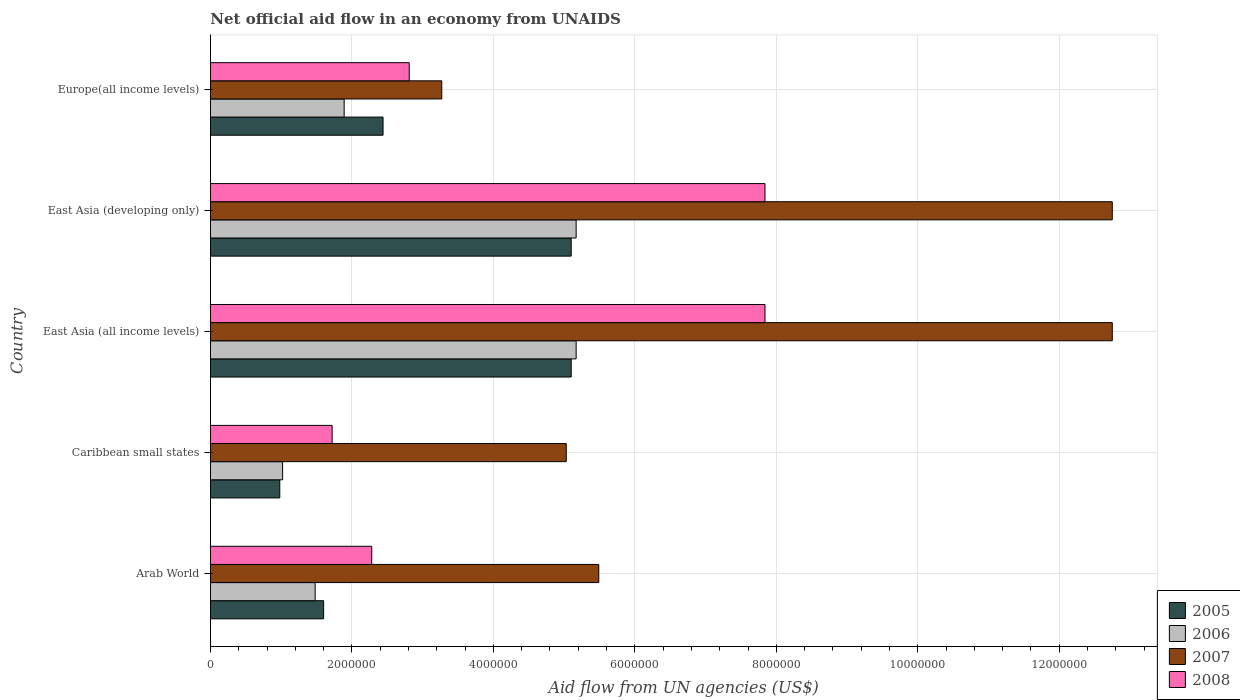How many different coloured bars are there?
Keep it short and to the point. 4. Are the number of bars on each tick of the Y-axis equal?
Offer a terse response. Yes. What is the label of the 4th group of bars from the top?
Give a very brief answer. Caribbean small states. In how many cases, is the number of bars for a given country not equal to the number of legend labels?
Provide a succinct answer. 0. What is the net official aid flow in 2008 in East Asia (developing only)?
Your answer should be compact. 7.84e+06. Across all countries, what is the maximum net official aid flow in 2008?
Provide a succinct answer. 7.84e+06. Across all countries, what is the minimum net official aid flow in 2007?
Give a very brief answer. 3.27e+06. In which country was the net official aid flow in 2005 maximum?
Offer a terse response. East Asia (all income levels). In which country was the net official aid flow in 2008 minimum?
Offer a very short reply. Caribbean small states. What is the total net official aid flow in 2006 in the graph?
Provide a short and direct response. 1.47e+07. What is the difference between the net official aid flow in 2007 in East Asia (developing only) and that in Europe(all income levels)?
Your answer should be compact. 9.48e+06. What is the difference between the net official aid flow in 2005 in Arab World and the net official aid flow in 2008 in Caribbean small states?
Your response must be concise. -1.20e+05. What is the average net official aid flow in 2006 per country?
Your answer should be compact. 2.95e+06. What is the difference between the net official aid flow in 2005 and net official aid flow in 2006 in East Asia (all income levels)?
Provide a succinct answer. -7.00e+04. In how many countries, is the net official aid flow in 2006 greater than 10000000 US$?
Ensure brevity in your answer.  0. What is the ratio of the net official aid flow in 2008 in Caribbean small states to that in East Asia (developing only)?
Your answer should be very brief. 0.22. Is the difference between the net official aid flow in 2005 in Arab World and East Asia (developing only) greater than the difference between the net official aid flow in 2006 in Arab World and East Asia (developing only)?
Offer a terse response. Yes. What is the difference between the highest and the second highest net official aid flow in 2008?
Provide a short and direct response. 0. What is the difference between the highest and the lowest net official aid flow in 2006?
Make the answer very short. 4.15e+06. In how many countries, is the net official aid flow in 2006 greater than the average net official aid flow in 2006 taken over all countries?
Your answer should be very brief. 2. What does the 2nd bar from the top in Caribbean small states represents?
Your answer should be very brief. 2007. Is it the case that in every country, the sum of the net official aid flow in 2005 and net official aid flow in 2007 is greater than the net official aid flow in 2008?
Provide a short and direct response. Yes. Does the graph contain grids?
Offer a terse response. Yes. Where does the legend appear in the graph?
Ensure brevity in your answer.  Bottom right. What is the title of the graph?
Your answer should be very brief. Net official aid flow in an economy from UNAIDS. What is the label or title of the X-axis?
Offer a very short reply. Aid flow from UN agencies (US$). What is the label or title of the Y-axis?
Your answer should be compact. Country. What is the Aid flow from UN agencies (US$) of 2005 in Arab World?
Make the answer very short. 1.60e+06. What is the Aid flow from UN agencies (US$) of 2006 in Arab World?
Provide a short and direct response. 1.48e+06. What is the Aid flow from UN agencies (US$) of 2007 in Arab World?
Your response must be concise. 5.49e+06. What is the Aid flow from UN agencies (US$) in 2008 in Arab World?
Ensure brevity in your answer.  2.28e+06. What is the Aid flow from UN agencies (US$) in 2005 in Caribbean small states?
Your answer should be compact. 9.80e+05. What is the Aid flow from UN agencies (US$) in 2006 in Caribbean small states?
Give a very brief answer. 1.02e+06. What is the Aid flow from UN agencies (US$) in 2007 in Caribbean small states?
Your answer should be compact. 5.03e+06. What is the Aid flow from UN agencies (US$) in 2008 in Caribbean small states?
Your response must be concise. 1.72e+06. What is the Aid flow from UN agencies (US$) of 2005 in East Asia (all income levels)?
Make the answer very short. 5.10e+06. What is the Aid flow from UN agencies (US$) of 2006 in East Asia (all income levels)?
Ensure brevity in your answer.  5.17e+06. What is the Aid flow from UN agencies (US$) of 2007 in East Asia (all income levels)?
Provide a short and direct response. 1.28e+07. What is the Aid flow from UN agencies (US$) of 2008 in East Asia (all income levels)?
Your response must be concise. 7.84e+06. What is the Aid flow from UN agencies (US$) of 2005 in East Asia (developing only)?
Offer a terse response. 5.10e+06. What is the Aid flow from UN agencies (US$) of 2006 in East Asia (developing only)?
Your answer should be very brief. 5.17e+06. What is the Aid flow from UN agencies (US$) of 2007 in East Asia (developing only)?
Give a very brief answer. 1.28e+07. What is the Aid flow from UN agencies (US$) in 2008 in East Asia (developing only)?
Give a very brief answer. 7.84e+06. What is the Aid flow from UN agencies (US$) in 2005 in Europe(all income levels)?
Offer a terse response. 2.44e+06. What is the Aid flow from UN agencies (US$) of 2006 in Europe(all income levels)?
Offer a very short reply. 1.89e+06. What is the Aid flow from UN agencies (US$) of 2007 in Europe(all income levels)?
Ensure brevity in your answer.  3.27e+06. What is the Aid flow from UN agencies (US$) of 2008 in Europe(all income levels)?
Offer a very short reply. 2.81e+06. Across all countries, what is the maximum Aid flow from UN agencies (US$) of 2005?
Offer a terse response. 5.10e+06. Across all countries, what is the maximum Aid flow from UN agencies (US$) of 2006?
Provide a short and direct response. 5.17e+06. Across all countries, what is the maximum Aid flow from UN agencies (US$) of 2007?
Provide a short and direct response. 1.28e+07. Across all countries, what is the maximum Aid flow from UN agencies (US$) in 2008?
Offer a very short reply. 7.84e+06. Across all countries, what is the minimum Aid flow from UN agencies (US$) of 2005?
Your answer should be very brief. 9.80e+05. Across all countries, what is the minimum Aid flow from UN agencies (US$) of 2006?
Provide a short and direct response. 1.02e+06. Across all countries, what is the minimum Aid flow from UN agencies (US$) in 2007?
Provide a succinct answer. 3.27e+06. Across all countries, what is the minimum Aid flow from UN agencies (US$) of 2008?
Offer a terse response. 1.72e+06. What is the total Aid flow from UN agencies (US$) in 2005 in the graph?
Keep it short and to the point. 1.52e+07. What is the total Aid flow from UN agencies (US$) in 2006 in the graph?
Provide a succinct answer. 1.47e+07. What is the total Aid flow from UN agencies (US$) in 2007 in the graph?
Provide a short and direct response. 3.93e+07. What is the total Aid flow from UN agencies (US$) of 2008 in the graph?
Provide a succinct answer. 2.25e+07. What is the difference between the Aid flow from UN agencies (US$) of 2005 in Arab World and that in Caribbean small states?
Make the answer very short. 6.20e+05. What is the difference between the Aid flow from UN agencies (US$) of 2006 in Arab World and that in Caribbean small states?
Offer a terse response. 4.60e+05. What is the difference between the Aid flow from UN agencies (US$) in 2008 in Arab World and that in Caribbean small states?
Provide a short and direct response. 5.60e+05. What is the difference between the Aid flow from UN agencies (US$) of 2005 in Arab World and that in East Asia (all income levels)?
Keep it short and to the point. -3.50e+06. What is the difference between the Aid flow from UN agencies (US$) in 2006 in Arab World and that in East Asia (all income levels)?
Keep it short and to the point. -3.69e+06. What is the difference between the Aid flow from UN agencies (US$) in 2007 in Arab World and that in East Asia (all income levels)?
Your answer should be compact. -7.26e+06. What is the difference between the Aid flow from UN agencies (US$) in 2008 in Arab World and that in East Asia (all income levels)?
Your answer should be compact. -5.56e+06. What is the difference between the Aid flow from UN agencies (US$) in 2005 in Arab World and that in East Asia (developing only)?
Keep it short and to the point. -3.50e+06. What is the difference between the Aid flow from UN agencies (US$) in 2006 in Arab World and that in East Asia (developing only)?
Your response must be concise. -3.69e+06. What is the difference between the Aid flow from UN agencies (US$) in 2007 in Arab World and that in East Asia (developing only)?
Your response must be concise. -7.26e+06. What is the difference between the Aid flow from UN agencies (US$) of 2008 in Arab World and that in East Asia (developing only)?
Ensure brevity in your answer.  -5.56e+06. What is the difference between the Aid flow from UN agencies (US$) of 2005 in Arab World and that in Europe(all income levels)?
Provide a succinct answer. -8.40e+05. What is the difference between the Aid flow from UN agencies (US$) of 2006 in Arab World and that in Europe(all income levels)?
Your response must be concise. -4.10e+05. What is the difference between the Aid flow from UN agencies (US$) in 2007 in Arab World and that in Europe(all income levels)?
Your answer should be compact. 2.22e+06. What is the difference between the Aid flow from UN agencies (US$) of 2008 in Arab World and that in Europe(all income levels)?
Give a very brief answer. -5.30e+05. What is the difference between the Aid flow from UN agencies (US$) in 2005 in Caribbean small states and that in East Asia (all income levels)?
Make the answer very short. -4.12e+06. What is the difference between the Aid flow from UN agencies (US$) in 2006 in Caribbean small states and that in East Asia (all income levels)?
Keep it short and to the point. -4.15e+06. What is the difference between the Aid flow from UN agencies (US$) of 2007 in Caribbean small states and that in East Asia (all income levels)?
Your answer should be very brief. -7.72e+06. What is the difference between the Aid flow from UN agencies (US$) of 2008 in Caribbean small states and that in East Asia (all income levels)?
Your response must be concise. -6.12e+06. What is the difference between the Aid flow from UN agencies (US$) of 2005 in Caribbean small states and that in East Asia (developing only)?
Offer a terse response. -4.12e+06. What is the difference between the Aid flow from UN agencies (US$) in 2006 in Caribbean small states and that in East Asia (developing only)?
Offer a very short reply. -4.15e+06. What is the difference between the Aid flow from UN agencies (US$) of 2007 in Caribbean small states and that in East Asia (developing only)?
Your answer should be very brief. -7.72e+06. What is the difference between the Aid flow from UN agencies (US$) in 2008 in Caribbean small states and that in East Asia (developing only)?
Your answer should be very brief. -6.12e+06. What is the difference between the Aid flow from UN agencies (US$) in 2005 in Caribbean small states and that in Europe(all income levels)?
Give a very brief answer. -1.46e+06. What is the difference between the Aid flow from UN agencies (US$) of 2006 in Caribbean small states and that in Europe(all income levels)?
Ensure brevity in your answer.  -8.70e+05. What is the difference between the Aid flow from UN agencies (US$) in 2007 in Caribbean small states and that in Europe(all income levels)?
Your answer should be compact. 1.76e+06. What is the difference between the Aid flow from UN agencies (US$) of 2008 in Caribbean small states and that in Europe(all income levels)?
Offer a terse response. -1.09e+06. What is the difference between the Aid flow from UN agencies (US$) of 2005 in East Asia (all income levels) and that in East Asia (developing only)?
Provide a succinct answer. 0. What is the difference between the Aid flow from UN agencies (US$) in 2005 in East Asia (all income levels) and that in Europe(all income levels)?
Your answer should be very brief. 2.66e+06. What is the difference between the Aid flow from UN agencies (US$) in 2006 in East Asia (all income levels) and that in Europe(all income levels)?
Make the answer very short. 3.28e+06. What is the difference between the Aid flow from UN agencies (US$) in 2007 in East Asia (all income levels) and that in Europe(all income levels)?
Provide a succinct answer. 9.48e+06. What is the difference between the Aid flow from UN agencies (US$) in 2008 in East Asia (all income levels) and that in Europe(all income levels)?
Give a very brief answer. 5.03e+06. What is the difference between the Aid flow from UN agencies (US$) in 2005 in East Asia (developing only) and that in Europe(all income levels)?
Your response must be concise. 2.66e+06. What is the difference between the Aid flow from UN agencies (US$) of 2006 in East Asia (developing only) and that in Europe(all income levels)?
Ensure brevity in your answer.  3.28e+06. What is the difference between the Aid flow from UN agencies (US$) of 2007 in East Asia (developing only) and that in Europe(all income levels)?
Keep it short and to the point. 9.48e+06. What is the difference between the Aid flow from UN agencies (US$) in 2008 in East Asia (developing only) and that in Europe(all income levels)?
Offer a very short reply. 5.03e+06. What is the difference between the Aid flow from UN agencies (US$) in 2005 in Arab World and the Aid flow from UN agencies (US$) in 2006 in Caribbean small states?
Your response must be concise. 5.80e+05. What is the difference between the Aid flow from UN agencies (US$) in 2005 in Arab World and the Aid flow from UN agencies (US$) in 2007 in Caribbean small states?
Ensure brevity in your answer.  -3.43e+06. What is the difference between the Aid flow from UN agencies (US$) in 2005 in Arab World and the Aid flow from UN agencies (US$) in 2008 in Caribbean small states?
Give a very brief answer. -1.20e+05. What is the difference between the Aid flow from UN agencies (US$) in 2006 in Arab World and the Aid flow from UN agencies (US$) in 2007 in Caribbean small states?
Provide a short and direct response. -3.55e+06. What is the difference between the Aid flow from UN agencies (US$) of 2006 in Arab World and the Aid flow from UN agencies (US$) of 2008 in Caribbean small states?
Offer a very short reply. -2.40e+05. What is the difference between the Aid flow from UN agencies (US$) of 2007 in Arab World and the Aid flow from UN agencies (US$) of 2008 in Caribbean small states?
Offer a very short reply. 3.77e+06. What is the difference between the Aid flow from UN agencies (US$) of 2005 in Arab World and the Aid flow from UN agencies (US$) of 2006 in East Asia (all income levels)?
Keep it short and to the point. -3.57e+06. What is the difference between the Aid flow from UN agencies (US$) in 2005 in Arab World and the Aid flow from UN agencies (US$) in 2007 in East Asia (all income levels)?
Your answer should be very brief. -1.12e+07. What is the difference between the Aid flow from UN agencies (US$) in 2005 in Arab World and the Aid flow from UN agencies (US$) in 2008 in East Asia (all income levels)?
Provide a succinct answer. -6.24e+06. What is the difference between the Aid flow from UN agencies (US$) of 2006 in Arab World and the Aid flow from UN agencies (US$) of 2007 in East Asia (all income levels)?
Your answer should be very brief. -1.13e+07. What is the difference between the Aid flow from UN agencies (US$) of 2006 in Arab World and the Aid flow from UN agencies (US$) of 2008 in East Asia (all income levels)?
Make the answer very short. -6.36e+06. What is the difference between the Aid flow from UN agencies (US$) of 2007 in Arab World and the Aid flow from UN agencies (US$) of 2008 in East Asia (all income levels)?
Give a very brief answer. -2.35e+06. What is the difference between the Aid flow from UN agencies (US$) in 2005 in Arab World and the Aid flow from UN agencies (US$) in 2006 in East Asia (developing only)?
Provide a succinct answer. -3.57e+06. What is the difference between the Aid flow from UN agencies (US$) in 2005 in Arab World and the Aid flow from UN agencies (US$) in 2007 in East Asia (developing only)?
Keep it short and to the point. -1.12e+07. What is the difference between the Aid flow from UN agencies (US$) of 2005 in Arab World and the Aid flow from UN agencies (US$) of 2008 in East Asia (developing only)?
Keep it short and to the point. -6.24e+06. What is the difference between the Aid flow from UN agencies (US$) of 2006 in Arab World and the Aid flow from UN agencies (US$) of 2007 in East Asia (developing only)?
Give a very brief answer. -1.13e+07. What is the difference between the Aid flow from UN agencies (US$) of 2006 in Arab World and the Aid flow from UN agencies (US$) of 2008 in East Asia (developing only)?
Offer a very short reply. -6.36e+06. What is the difference between the Aid flow from UN agencies (US$) in 2007 in Arab World and the Aid flow from UN agencies (US$) in 2008 in East Asia (developing only)?
Your answer should be very brief. -2.35e+06. What is the difference between the Aid flow from UN agencies (US$) of 2005 in Arab World and the Aid flow from UN agencies (US$) of 2007 in Europe(all income levels)?
Offer a terse response. -1.67e+06. What is the difference between the Aid flow from UN agencies (US$) of 2005 in Arab World and the Aid flow from UN agencies (US$) of 2008 in Europe(all income levels)?
Offer a terse response. -1.21e+06. What is the difference between the Aid flow from UN agencies (US$) in 2006 in Arab World and the Aid flow from UN agencies (US$) in 2007 in Europe(all income levels)?
Give a very brief answer. -1.79e+06. What is the difference between the Aid flow from UN agencies (US$) in 2006 in Arab World and the Aid flow from UN agencies (US$) in 2008 in Europe(all income levels)?
Offer a terse response. -1.33e+06. What is the difference between the Aid flow from UN agencies (US$) of 2007 in Arab World and the Aid flow from UN agencies (US$) of 2008 in Europe(all income levels)?
Ensure brevity in your answer.  2.68e+06. What is the difference between the Aid flow from UN agencies (US$) of 2005 in Caribbean small states and the Aid flow from UN agencies (US$) of 2006 in East Asia (all income levels)?
Give a very brief answer. -4.19e+06. What is the difference between the Aid flow from UN agencies (US$) in 2005 in Caribbean small states and the Aid flow from UN agencies (US$) in 2007 in East Asia (all income levels)?
Make the answer very short. -1.18e+07. What is the difference between the Aid flow from UN agencies (US$) in 2005 in Caribbean small states and the Aid flow from UN agencies (US$) in 2008 in East Asia (all income levels)?
Provide a succinct answer. -6.86e+06. What is the difference between the Aid flow from UN agencies (US$) of 2006 in Caribbean small states and the Aid flow from UN agencies (US$) of 2007 in East Asia (all income levels)?
Keep it short and to the point. -1.17e+07. What is the difference between the Aid flow from UN agencies (US$) of 2006 in Caribbean small states and the Aid flow from UN agencies (US$) of 2008 in East Asia (all income levels)?
Provide a short and direct response. -6.82e+06. What is the difference between the Aid flow from UN agencies (US$) of 2007 in Caribbean small states and the Aid flow from UN agencies (US$) of 2008 in East Asia (all income levels)?
Your response must be concise. -2.81e+06. What is the difference between the Aid flow from UN agencies (US$) in 2005 in Caribbean small states and the Aid flow from UN agencies (US$) in 2006 in East Asia (developing only)?
Make the answer very short. -4.19e+06. What is the difference between the Aid flow from UN agencies (US$) of 2005 in Caribbean small states and the Aid flow from UN agencies (US$) of 2007 in East Asia (developing only)?
Your answer should be very brief. -1.18e+07. What is the difference between the Aid flow from UN agencies (US$) in 2005 in Caribbean small states and the Aid flow from UN agencies (US$) in 2008 in East Asia (developing only)?
Provide a succinct answer. -6.86e+06. What is the difference between the Aid flow from UN agencies (US$) in 2006 in Caribbean small states and the Aid flow from UN agencies (US$) in 2007 in East Asia (developing only)?
Your answer should be compact. -1.17e+07. What is the difference between the Aid flow from UN agencies (US$) of 2006 in Caribbean small states and the Aid flow from UN agencies (US$) of 2008 in East Asia (developing only)?
Give a very brief answer. -6.82e+06. What is the difference between the Aid flow from UN agencies (US$) of 2007 in Caribbean small states and the Aid flow from UN agencies (US$) of 2008 in East Asia (developing only)?
Give a very brief answer. -2.81e+06. What is the difference between the Aid flow from UN agencies (US$) of 2005 in Caribbean small states and the Aid flow from UN agencies (US$) of 2006 in Europe(all income levels)?
Your answer should be compact. -9.10e+05. What is the difference between the Aid flow from UN agencies (US$) of 2005 in Caribbean small states and the Aid flow from UN agencies (US$) of 2007 in Europe(all income levels)?
Offer a terse response. -2.29e+06. What is the difference between the Aid flow from UN agencies (US$) of 2005 in Caribbean small states and the Aid flow from UN agencies (US$) of 2008 in Europe(all income levels)?
Your response must be concise. -1.83e+06. What is the difference between the Aid flow from UN agencies (US$) of 2006 in Caribbean small states and the Aid flow from UN agencies (US$) of 2007 in Europe(all income levels)?
Offer a terse response. -2.25e+06. What is the difference between the Aid flow from UN agencies (US$) in 2006 in Caribbean small states and the Aid flow from UN agencies (US$) in 2008 in Europe(all income levels)?
Your response must be concise. -1.79e+06. What is the difference between the Aid flow from UN agencies (US$) in 2007 in Caribbean small states and the Aid flow from UN agencies (US$) in 2008 in Europe(all income levels)?
Provide a succinct answer. 2.22e+06. What is the difference between the Aid flow from UN agencies (US$) in 2005 in East Asia (all income levels) and the Aid flow from UN agencies (US$) in 2007 in East Asia (developing only)?
Provide a short and direct response. -7.65e+06. What is the difference between the Aid flow from UN agencies (US$) of 2005 in East Asia (all income levels) and the Aid flow from UN agencies (US$) of 2008 in East Asia (developing only)?
Offer a terse response. -2.74e+06. What is the difference between the Aid flow from UN agencies (US$) of 2006 in East Asia (all income levels) and the Aid flow from UN agencies (US$) of 2007 in East Asia (developing only)?
Provide a short and direct response. -7.58e+06. What is the difference between the Aid flow from UN agencies (US$) of 2006 in East Asia (all income levels) and the Aid flow from UN agencies (US$) of 2008 in East Asia (developing only)?
Offer a terse response. -2.67e+06. What is the difference between the Aid flow from UN agencies (US$) of 2007 in East Asia (all income levels) and the Aid flow from UN agencies (US$) of 2008 in East Asia (developing only)?
Provide a short and direct response. 4.91e+06. What is the difference between the Aid flow from UN agencies (US$) of 2005 in East Asia (all income levels) and the Aid flow from UN agencies (US$) of 2006 in Europe(all income levels)?
Provide a succinct answer. 3.21e+06. What is the difference between the Aid flow from UN agencies (US$) of 2005 in East Asia (all income levels) and the Aid flow from UN agencies (US$) of 2007 in Europe(all income levels)?
Ensure brevity in your answer.  1.83e+06. What is the difference between the Aid flow from UN agencies (US$) in 2005 in East Asia (all income levels) and the Aid flow from UN agencies (US$) in 2008 in Europe(all income levels)?
Offer a terse response. 2.29e+06. What is the difference between the Aid flow from UN agencies (US$) of 2006 in East Asia (all income levels) and the Aid flow from UN agencies (US$) of 2007 in Europe(all income levels)?
Keep it short and to the point. 1.90e+06. What is the difference between the Aid flow from UN agencies (US$) of 2006 in East Asia (all income levels) and the Aid flow from UN agencies (US$) of 2008 in Europe(all income levels)?
Your response must be concise. 2.36e+06. What is the difference between the Aid flow from UN agencies (US$) in 2007 in East Asia (all income levels) and the Aid flow from UN agencies (US$) in 2008 in Europe(all income levels)?
Make the answer very short. 9.94e+06. What is the difference between the Aid flow from UN agencies (US$) in 2005 in East Asia (developing only) and the Aid flow from UN agencies (US$) in 2006 in Europe(all income levels)?
Offer a very short reply. 3.21e+06. What is the difference between the Aid flow from UN agencies (US$) in 2005 in East Asia (developing only) and the Aid flow from UN agencies (US$) in 2007 in Europe(all income levels)?
Keep it short and to the point. 1.83e+06. What is the difference between the Aid flow from UN agencies (US$) of 2005 in East Asia (developing only) and the Aid flow from UN agencies (US$) of 2008 in Europe(all income levels)?
Give a very brief answer. 2.29e+06. What is the difference between the Aid flow from UN agencies (US$) in 2006 in East Asia (developing only) and the Aid flow from UN agencies (US$) in 2007 in Europe(all income levels)?
Offer a very short reply. 1.90e+06. What is the difference between the Aid flow from UN agencies (US$) in 2006 in East Asia (developing only) and the Aid flow from UN agencies (US$) in 2008 in Europe(all income levels)?
Offer a very short reply. 2.36e+06. What is the difference between the Aid flow from UN agencies (US$) in 2007 in East Asia (developing only) and the Aid flow from UN agencies (US$) in 2008 in Europe(all income levels)?
Make the answer very short. 9.94e+06. What is the average Aid flow from UN agencies (US$) in 2005 per country?
Offer a terse response. 3.04e+06. What is the average Aid flow from UN agencies (US$) of 2006 per country?
Offer a terse response. 2.95e+06. What is the average Aid flow from UN agencies (US$) of 2007 per country?
Provide a short and direct response. 7.86e+06. What is the average Aid flow from UN agencies (US$) of 2008 per country?
Ensure brevity in your answer.  4.50e+06. What is the difference between the Aid flow from UN agencies (US$) of 2005 and Aid flow from UN agencies (US$) of 2007 in Arab World?
Provide a succinct answer. -3.89e+06. What is the difference between the Aid flow from UN agencies (US$) of 2005 and Aid flow from UN agencies (US$) of 2008 in Arab World?
Ensure brevity in your answer.  -6.80e+05. What is the difference between the Aid flow from UN agencies (US$) of 2006 and Aid flow from UN agencies (US$) of 2007 in Arab World?
Your answer should be compact. -4.01e+06. What is the difference between the Aid flow from UN agencies (US$) of 2006 and Aid flow from UN agencies (US$) of 2008 in Arab World?
Offer a very short reply. -8.00e+05. What is the difference between the Aid flow from UN agencies (US$) of 2007 and Aid flow from UN agencies (US$) of 2008 in Arab World?
Your answer should be very brief. 3.21e+06. What is the difference between the Aid flow from UN agencies (US$) of 2005 and Aid flow from UN agencies (US$) of 2006 in Caribbean small states?
Provide a succinct answer. -4.00e+04. What is the difference between the Aid flow from UN agencies (US$) in 2005 and Aid flow from UN agencies (US$) in 2007 in Caribbean small states?
Your response must be concise. -4.05e+06. What is the difference between the Aid flow from UN agencies (US$) of 2005 and Aid flow from UN agencies (US$) of 2008 in Caribbean small states?
Your response must be concise. -7.40e+05. What is the difference between the Aid flow from UN agencies (US$) in 2006 and Aid flow from UN agencies (US$) in 2007 in Caribbean small states?
Your answer should be very brief. -4.01e+06. What is the difference between the Aid flow from UN agencies (US$) in 2006 and Aid flow from UN agencies (US$) in 2008 in Caribbean small states?
Ensure brevity in your answer.  -7.00e+05. What is the difference between the Aid flow from UN agencies (US$) of 2007 and Aid flow from UN agencies (US$) of 2008 in Caribbean small states?
Keep it short and to the point. 3.31e+06. What is the difference between the Aid flow from UN agencies (US$) of 2005 and Aid flow from UN agencies (US$) of 2007 in East Asia (all income levels)?
Provide a succinct answer. -7.65e+06. What is the difference between the Aid flow from UN agencies (US$) of 2005 and Aid flow from UN agencies (US$) of 2008 in East Asia (all income levels)?
Provide a succinct answer. -2.74e+06. What is the difference between the Aid flow from UN agencies (US$) of 2006 and Aid flow from UN agencies (US$) of 2007 in East Asia (all income levels)?
Your response must be concise. -7.58e+06. What is the difference between the Aid flow from UN agencies (US$) in 2006 and Aid flow from UN agencies (US$) in 2008 in East Asia (all income levels)?
Provide a succinct answer. -2.67e+06. What is the difference between the Aid flow from UN agencies (US$) in 2007 and Aid flow from UN agencies (US$) in 2008 in East Asia (all income levels)?
Provide a short and direct response. 4.91e+06. What is the difference between the Aid flow from UN agencies (US$) of 2005 and Aid flow from UN agencies (US$) of 2007 in East Asia (developing only)?
Keep it short and to the point. -7.65e+06. What is the difference between the Aid flow from UN agencies (US$) of 2005 and Aid flow from UN agencies (US$) of 2008 in East Asia (developing only)?
Your answer should be very brief. -2.74e+06. What is the difference between the Aid flow from UN agencies (US$) in 2006 and Aid flow from UN agencies (US$) in 2007 in East Asia (developing only)?
Make the answer very short. -7.58e+06. What is the difference between the Aid flow from UN agencies (US$) of 2006 and Aid flow from UN agencies (US$) of 2008 in East Asia (developing only)?
Your answer should be very brief. -2.67e+06. What is the difference between the Aid flow from UN agencies (US$) in 2007 and Aid flow from UN agencies (US$) in 2008 in East Asia (developing only)?
Make the answer very short. 4.91e+06. What is the difference between the Aid flow from UN agencies (US$) of 2005 and Aid flow from UN agencies (US$) of 2006 in Europe(all income levels)?
Keep it short and to the point. 5.50e+05. What is the difference between the Aid flow from UN agencies (US$) in 2005 and Aid flow from UN agencies (US$) in 2007 in Europe(all income levels)?
Your answer should be compact. -8.30e+05. What is the difference between the Aid flow from UN agencies (US$) of 2005 and Aid flow from UN agencies (US$) of 2008 in Europe(all income levels)?
Provide a succinct answer. -3.70e+05. What is the difference between the Aid flow from UN agencies (US$) in 2006 and Aid flow from UN agencies (US$) in 2007 in Europe(all income levels)?
Make the answer very short. -1.38e+06. What is the difference between the Aid flow from UN agencies (US$) in 2006 and Aid flow from UN agencies (US$) in 2008 in Europe(all income levels)?
Offer a very short reply. -9.20e+05. What is the difference between the Aid flow from UN agencies (US$) of 2007 and Aid flow from UN agencies (US$) of 2008 in Europe(all income levels)?
Offer a very short reply. 4.60e+05. What is the ratio of the Aid flow from UN agencies (US$) of 2005 in Arab World to that in Caribbean small states?
Keep it short and to the point. 1.63. What is the ratio of the Aid flow from UN agencies (US$) in 2006 in Arab World to that in Caribbean small states?
Ensure brevity in your answer.  1.45. What is the ratio of the Aid flow from UN agencies (US$) in 2007 in Arab World to that in Caribbean small states?
Provide a succinct answer. 1.09. What is the ratio of the Aid flow from UN agencies (US$) in 2008 in Arab World to that in Caribbean small states?
Make the answer very short. 1.33. What is the ratio of the Aid flow from UN agencies (US$) of 2005 in Arab World to that in East Asia (all income levels)?
Provide a succinct answer. 0.31. What is the ratio of the Aid flow from UN agencies (US$) of 2006 in Arab World to that in East Asia (all income levels)?
Give a very brief answer. 0.29. What is the ratio of the Aid flow from UN agencies (US$) in 2007 in Arab World to that in East Asia (all income levels)?
Ensure brevity in your answer.  0.43. What is the ratio of the Aid flow from UN agencies (US$) in 2008 in Arab World to that in East Asia (all income levels)?
Keep it short and to the point. 0.29. What is the ratio of the Aid flow from UN agencies (US$) in 2005 in Arab World to that in East Asia (developing only)?
Make the answer very short. 0.31. What is the ratio of the Aid flow from UN agencies (US$) in 2006 in Arab World to that in East Asia (developing only)?
Your answer should be compact. 0.29. What is the ratio of the Aid flow from UN agencies (US$) of 2007 in Arab World to that in East Asia (developing only)?
Make the answer very short. 0.43. What is the ratio of the Aid flow from UN agencies (US$) of 2008 in Arab World to that in East Asia (developing only)?
Offer a terse response. 0.29. What is the ratio of the Aid flow from UN agencies (US$) of 2005 in Arab World to that in Europe(all income levels)?
Provide a short and direct response. 0.66. What is the ratio of the Aid flow from UN agencies (US$) in 2006 in Arab World to that in Europe(all income levels)?
Offer a very short reply. 0.78. What is the ratio of the Aid flow from UN agencies (US$) in 2007 in Arab World to that in Europe(all income levels)?
Your response must be concise. 1.68. What is the ratio of the Aid flow from UN agencies (US$) in 2008 in Arab World to that in Europe(all income levels)?
Provide a succinct answer. 0.81. What is the ratio of the Aid flow from UN agencies (US$) in 2005 in Caribbean small states to that in East Asia (all income levels)?
Ensure brevity in your answer.  0.19. What is the ratio of the Aid flow from UN agencies (US$) of 2006 in Caribbean small states to that in East Asia (all income levels)?
Give a very brief answer. 0.2. What is the ratio of the Aid flow from UN agencies (US$) of 2007 in Caribbean small states to that in East Asia (all income levels)?
Offer a very short reply. 0.39. What is the ratio of the Aid flow from UN agencies (US$) in 2008 in Caribbean small states to that in East Asia (all income levels)?
Your answer should be compact. 0.22. What is the ratio of the Aid flow from UN agencies (US$) of 2005 in Caribbean small states to that in East Asia (developing only)?
Offer a terse response. 0.19. What is the ratio of the Aid flow from UN agencies (US$) in 2006 in Caribbean small states to that in East Asia (developing only)?
Offer a very short reply. 0.2. What is the ratio of the Aid flow from UN agencies (US$) in 2007 in Caribbean small states to that in East Asia (developing only)?
Your answer should be compact. 0.39. What is the ratio of the Aid flow from UN agencies (US$) in 2008 in Caribbean small states to that in East Asia (developing only)?
Give a very brief answer. 0.22. What is the ratio of the Aid flow from UN agencies (US$) in 2005 in Caribbean small states to that in Europe(all income levels)?
Your response must be concise. 0.4. What is the ratio of the Aid flow from UN agencies (US$) of 2006 in Caribbean small states to that in Europe(all income levels)?
Your answer should be compact. 0.54. What is the ratio of the Aid flow from UN agencies (US$) in 2007 in Caribbean small states to that in Europe(all income levels)?
Offer a very short reply. 1.54. What is the ratio of the Aid flow from UN agencies (US$) of 2008 in Caribbean small states to that in Europe(all income levels)?
Provide a short and direct response. 0.61. What is the ratio of the Aid flow from UN agencies (US$) of 2005 in East Asia (all income levels) to that in East Asia (developing only)?
Ensure brevity in your answer.  1. What is the ratio of the Aid flow from UN agencies (US$) in 2008 in East Asia (all income levels) to that in East Asia (developing only)?
Make the answer very short. 1. What is the ratio of the Aid flow from UN agencies (US$) in 2005 in East Asia (all income levels) to that in Europe(all income levels)?
Your answer should be compact. 2.09. What is the ratio of the Aid flow from UN agencies (US$) in 2006 in East Asia (all income levels) to that in Europe(all income levels)?
Give a very brief answer. 2.74. What is the ratio of the Aid flow from UN agencies (US$) in 2007 in East Asia (all income levels) to that in Europe(all income levels)?
Give a very brief answer. 3.9. What is the ratio of the Aid flow from UN agencies (US$) of 2008 in East Asia (all income levels) to that in Europe(all income levels)?
Your answer should be very brief. 2.79. What is the ratio of the Aid flow from UN agencies (US$) in 2005 in East Asia (developing only) to that in Europe(all income levels)?
Keep it short and to the point. 2.09. What is the ratio of the Aid flow from UN agencies (US$) of 2006 in East Asia (developing only) to that in Europe(all income levels)?
Your response must be concise. 2.74. What is the ratio of the Aid flow from UN agencies (US$) in 2007 in East Asia (developing only) to that in Europe(all income levels)?
Make the answer very short. 3.9. What is the ratio of the Aid flow from UN agencies (US$) in 2008 in East Asia (developing only) to that in Europe(all income levels)?
Provide a short and direct response. 2.79. What is the difference between the highest and the second highest Aid flow from UN agencies (US$) in 2006?
Your answer should be compact. 0. What is the difference between the highest and the lowest Aid flow from UN agencies (US$) in 2005?
Your answer should be compact. 4.12e+06. What is the difference between the highest and the lowest Aid flow from UN agencies (US$) in 2006?
Offer a terse response. 4.15e+06. What is the difference between the highest and the lowest Aid flow from UN agencies (US$) of 2007?
Provide a succinct answer. 9.48e+06. What is the difference between the highest and the lowest Aid flow from UN agencies (US$) of 2008?
Ensure brevity in your answer.  6.12e+06. 